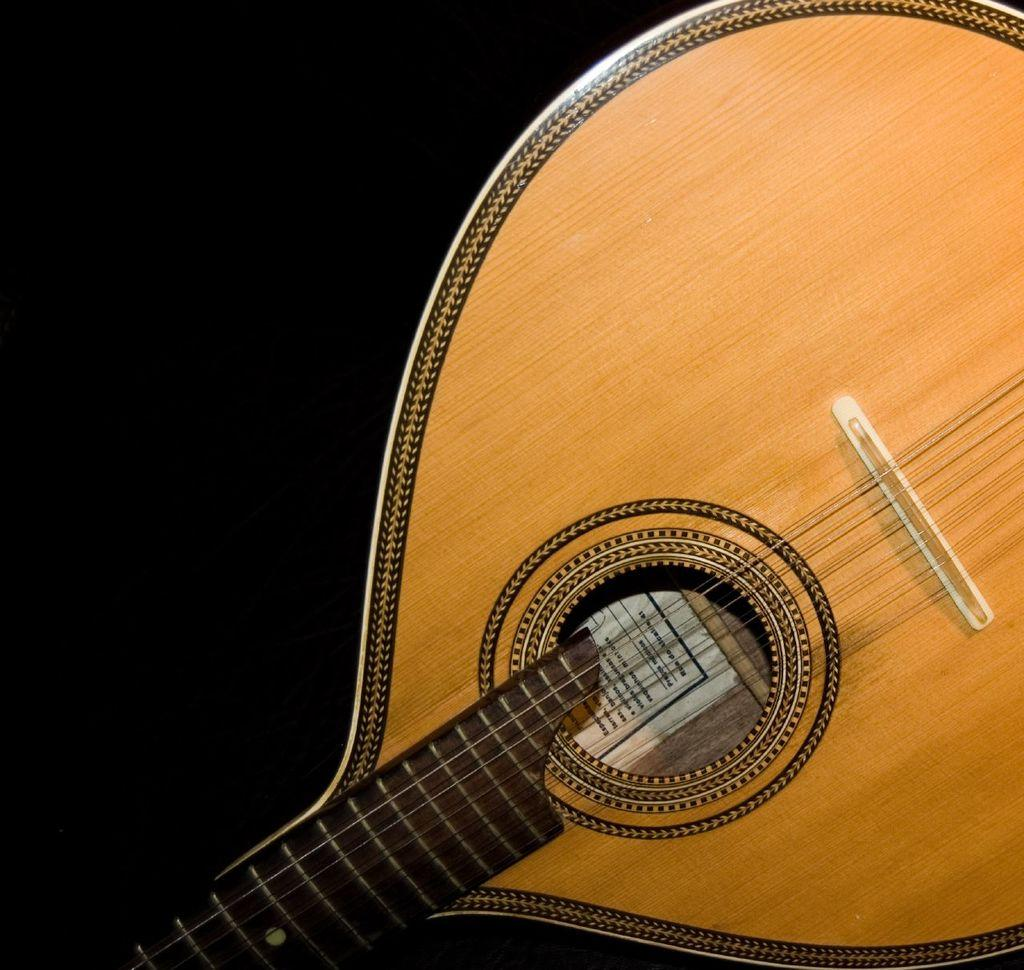What type of musical instrument is featured in the image? There is a wooden musical instrument in the image. How is the wooden musical instrument emphasized in the image? The wooden musical instrument is highlighted in the image. What type of meat is being sold in the shop in the image? There is no shop or meat present in the image; it features a wooden musical instrument. Can you tell me how many ears are visible in the image? There are no ears visible in the image; it features a wooden musical instrument. 